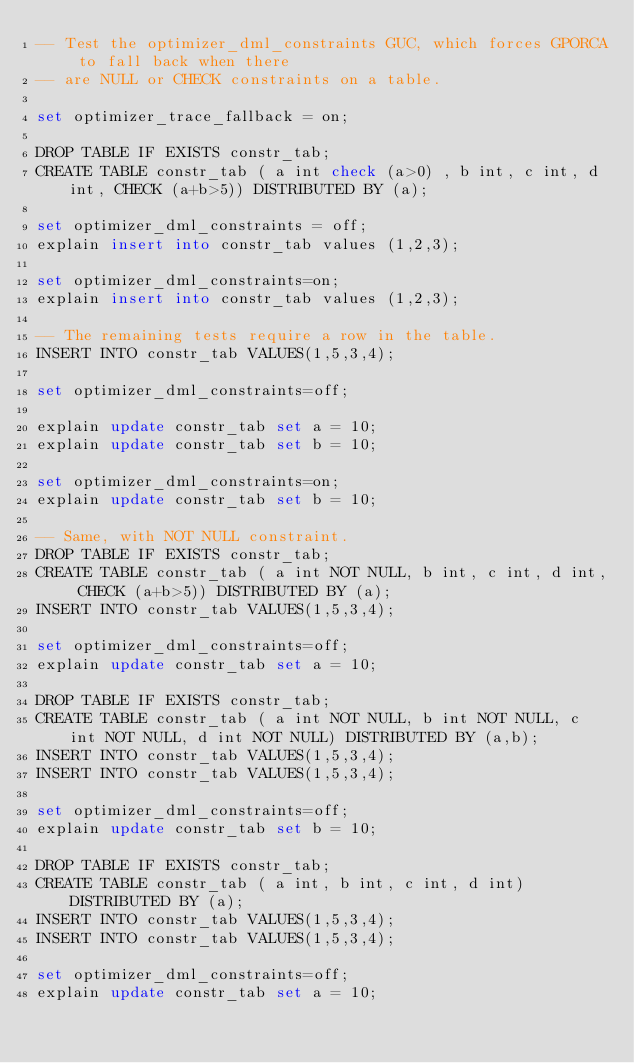<code> <loc_0><loc_0><loc_500><loc_500><_SQL_>-- Test the optimizer_dml_constraints GUC, which forces GPORCA to fall back when there
-- are NULL or CHECK constraints on a table.

set optimizer_trace_fallback = on;

DROP TABLE IF EXISTS constr_tab;
CREATE TABLE constr_tab ( a int check (a>0) , b int, c int, d int, CHECK (a+b>5)) DISTRIBUTED BY (a);

set optimizer_dml_constraints = off;
explain insert into constr_tab values (1,2,3);

set optimizer_dml_constraints=on;
explain insert into constr_tab values (1,2,3);

-- The remaining tests require a row in the table.
INSERT INTO constr_tab VALUES(1,5,3,4);

set optimizer_dml_constraints=off;

explain update constr_tab set a = 10;
explain update constr_tab set b = 10;

set optimizer_dml_constraints=on;
explain update constr_tab set b = 10;

-- Same, with NOT NULL constraint.
DROP TABLE IF EXISTS constr_tab;
CREATE TABLE constr_tab ( a int NOT NULL, b int, c int, d int, CHECK (a+b>5)) DISTRIBUTED BY (a);
INSERT INTO constr_tab VALUES(1,5,3,4);

set optimizer_dml_constraints=off;
explain update constr_tab set a = 10;

DROP TABLE IF EXISTS constr_tab;
CREATE TABLE constr_tab ( a int NOT NULL, b int NOT NULL, c int NOT NULL, d int NOT NULL) DISTRIBUTED BY (a,b);
INSERT INTO constr_tab VALUES(1,5,3,4);
INSERT INTO constr_tab VALUES(1,5,3,4);

set optimizer_dml_constraints=off;
explain update constr_tab set b = 10;

DROP TABLE IF EXISTS constr_tab;
CREATE TABLE constr_tab ( a int, b int, c int, d int) DISTRIBUTED BY (a);
INSERT INTO constr_tab VALUES(1,5,3,4);
INSERT INTO constr_tab VALUES(1,5,3,4);

set optimizer_dml_constraints=off;
explain update constr_tab set a = 10;
</code> 